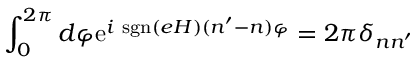Convert formula to latex. <formula><loc_0><loc_0><loc_500><loc_500>\int _ { 0 } ^ { 2 \pi } d \varphi e ^ { i s g n ( e H ) ( n ^ { \prime } - n ) \varphi } = 2 \pi \delta _ { n n ^ { \prime } }</formula> 